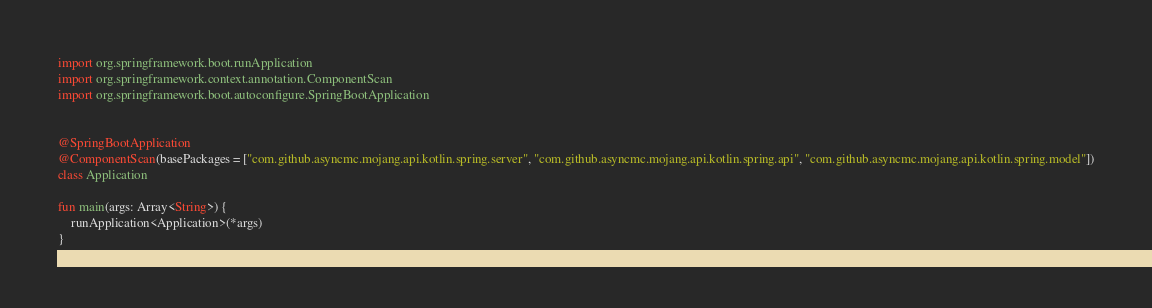Convert code to text. <code><loc_0><loc_0><loc_500><loc_500><_Kotlin_>import org.springframework.boot.runApplication
import org.springframework.context.annotation.ComponentScan
import org.springframework.boot.autoconfigure.SpringBootApplication


@SpringBootApplication
@ComponentScan(basePackages = ["com.github.asyncmc.mojang.api.kotlin.spring.server", "com.github.asyncmc.mojang.api.kotlin.spring.api", "com.github.asyncmc.mojang.api.kotlin.spring.model"])
class Application

fun main(args: Array<String>) {
    runApplication<Application>(*args)
}
</code> 